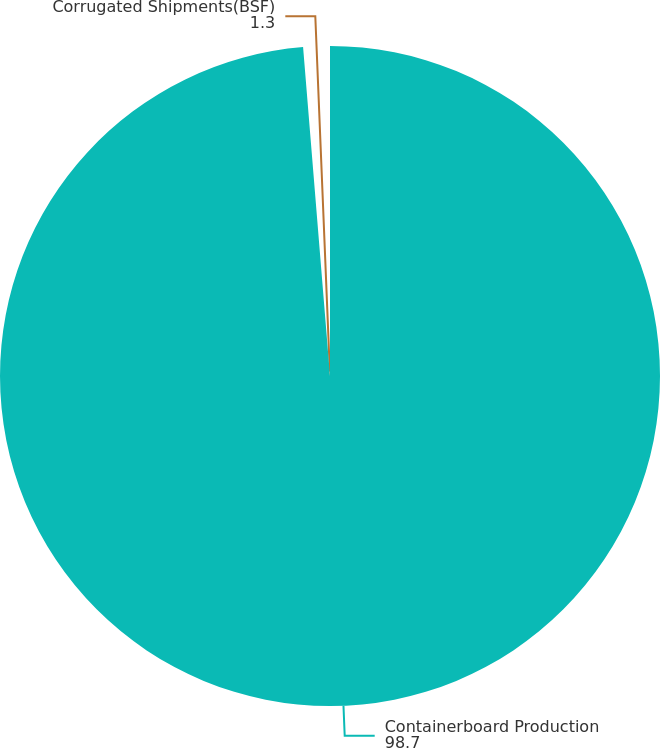Convert chart to OTSL. <chart><loc_0><loc_0><loc_500><loc_500><pie_chart><fcel>Containerboard Production<fcel>Corrugated Shipments(BSF)<nl><fcel>98.7%<fcel>1.3%<nl></chart> 